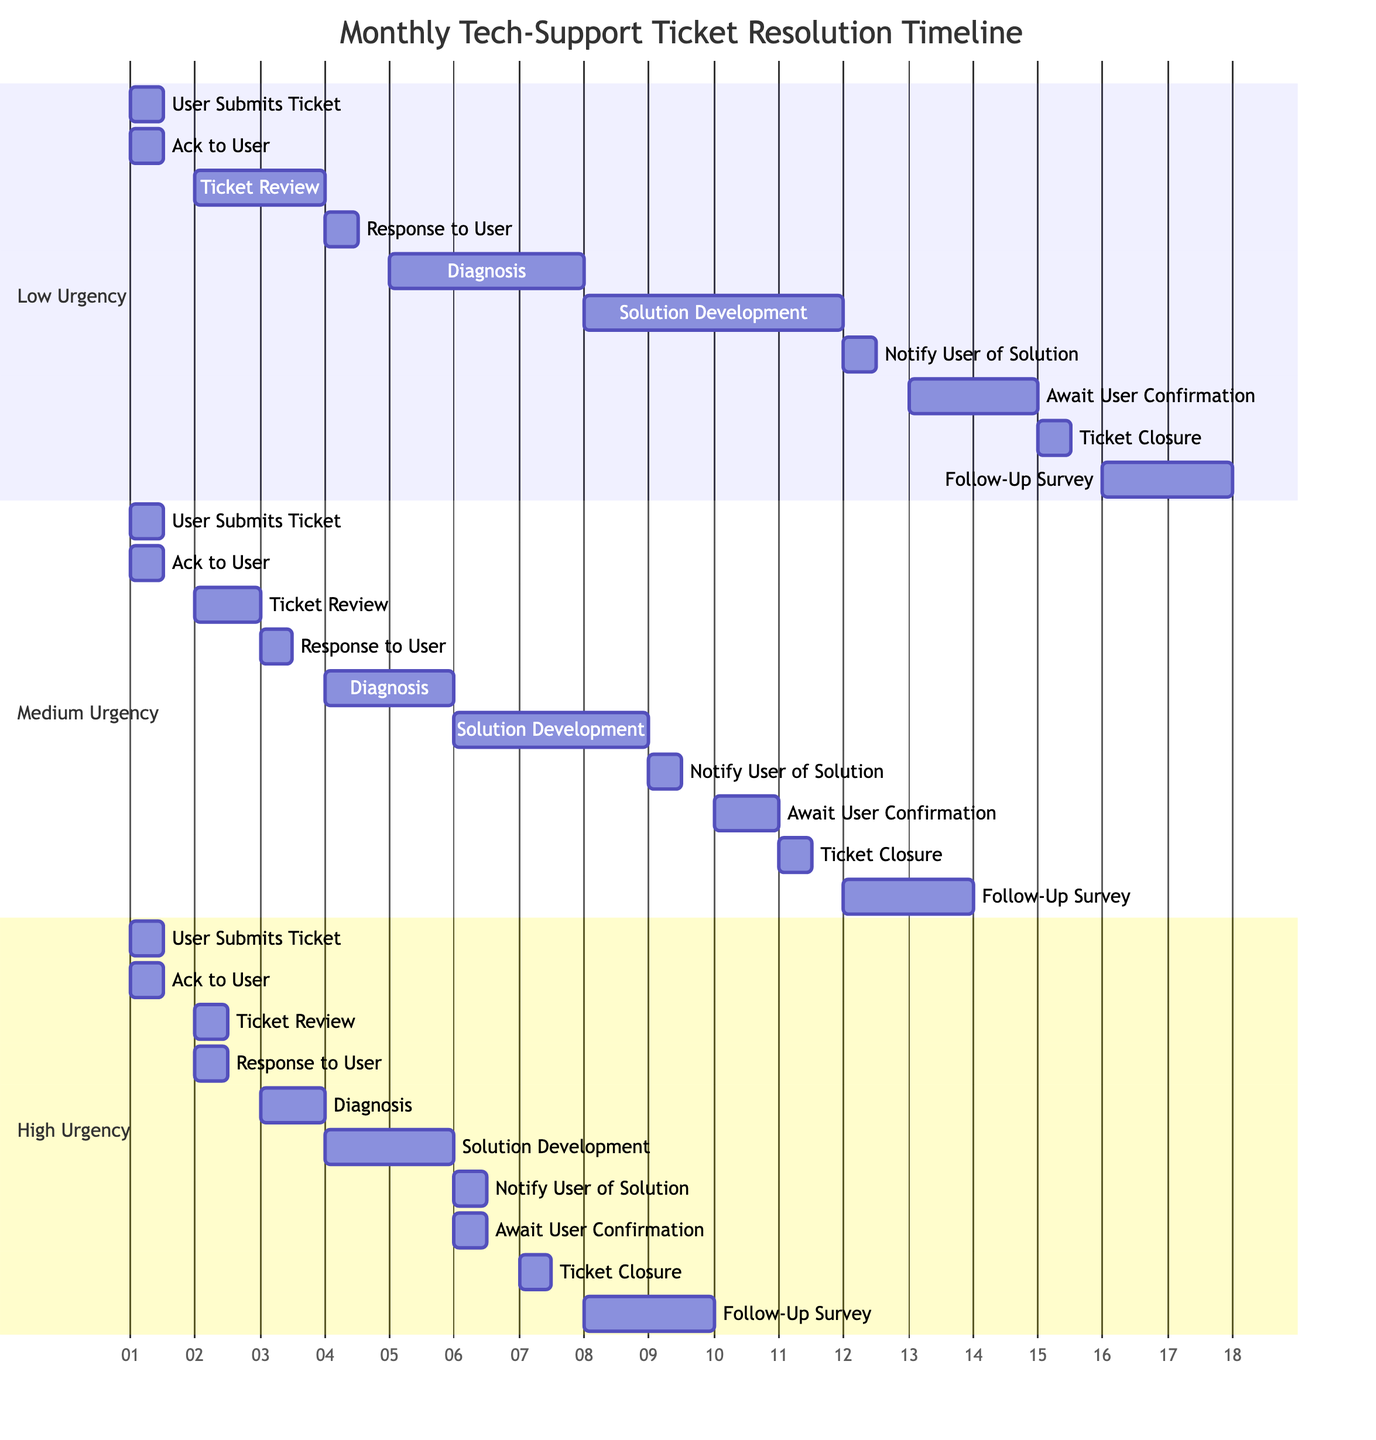What are the total stages in the Gantt chart? There are five stages in the Gantt chart: Ticket Submission, Initial Response, Troubleshooting, Follow-Up, and Resolution.
Answer: 5 Which task takes the longest duration under Low urgency? Under Low urgency, the task "Solution Development" takes the longest duration, which is 4 days.
Answer: 4 days How long does it take to complete the "Diagnosis" task for High urgency? For High urgency, the "Diagnosis" task takes 1 day to complete.
Answer: 1 day What is the duration for "Await User Confirmation" under Medium urgency? The "Await User Confirmation" task under Medium urgency takes 1 day, as stated in the diagram.
Answer: 1 day Which urgency level allows for the quick response to the user after ticket submission? The High urgency level has the quickest response, with the "Response to User" task taking only 12 hours following "Ticket Review."
Answer: High What is the total time taken from ticket submission to ticket closure for Low urgency? For Low urgency, the total time from "User Submits Ticket" to "Ticket Closure" is 15 days (0.5 + 0.5 + 2 + 0.5 + 3 + 4 + 0.5 + 2 + 0.5 = 15 days).
Answer: 15 days Which task in the "Follow-Up" stage has the same duration across all urgency levels? The task "Notify User of Solution" has the same duration of 0.5 days for all urgency levels according to the diagram.
Answer: Notify User of Solution What task immediately follows "Solution Development" in the Troubleshooting stage for Medium urgency? For Medium urgency, the task that immediately follows "Solution Development" is "Notify User of Solution."
Answer: Notify User of Solution What is the duration difference between "Ticket Review" tasks for Low and High urgency? The duration difference for "Ticket Review" is 0.5 days, where Low urgency takes 2 days and High urgency takes 1.5 days (2 - 1.5 = 0.5).
Answer: 0.5 days 